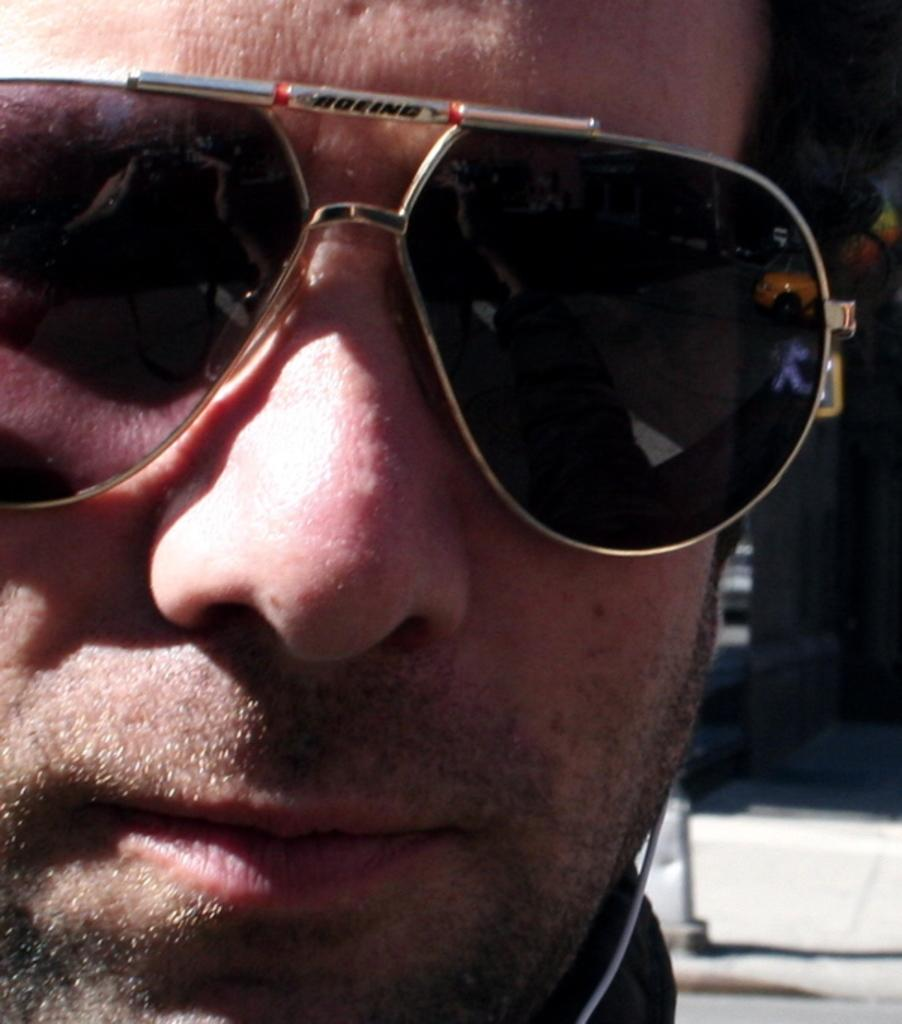Who or what is present in the image? There is a person in the image. What accessory is the person wearing? The person is wearing glasses. What can be seen behind the person in the image? There is a wall in the background of the image. What type of cast can be seen on the person's arm in the image? There is no cast visible on the person's arm in the image. What kind of jar is sitting on the table next to the person in the image? There is no jar present in the image. 